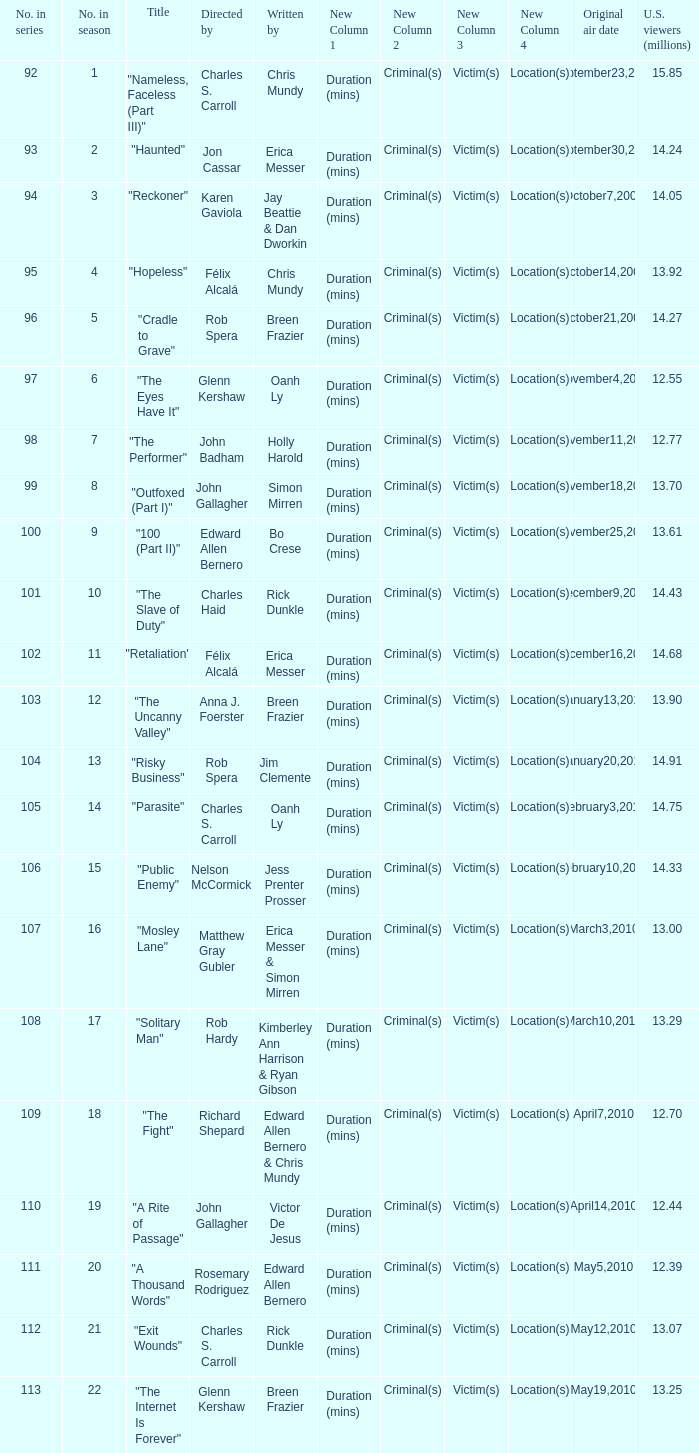What season was the episode "haunted" in? 2.0. 